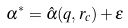Convert formula to latex. <formula><loc_0><loc_0><loc_500><loc_500>\alpha ^ { * } = \hat { \alpha } ( q , r _ { c } ) + \epsilon</formula> 